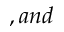Convert formula to latex. <formula><loc_0><loc_0><loc_500><loc_500>, a n d</formula> 